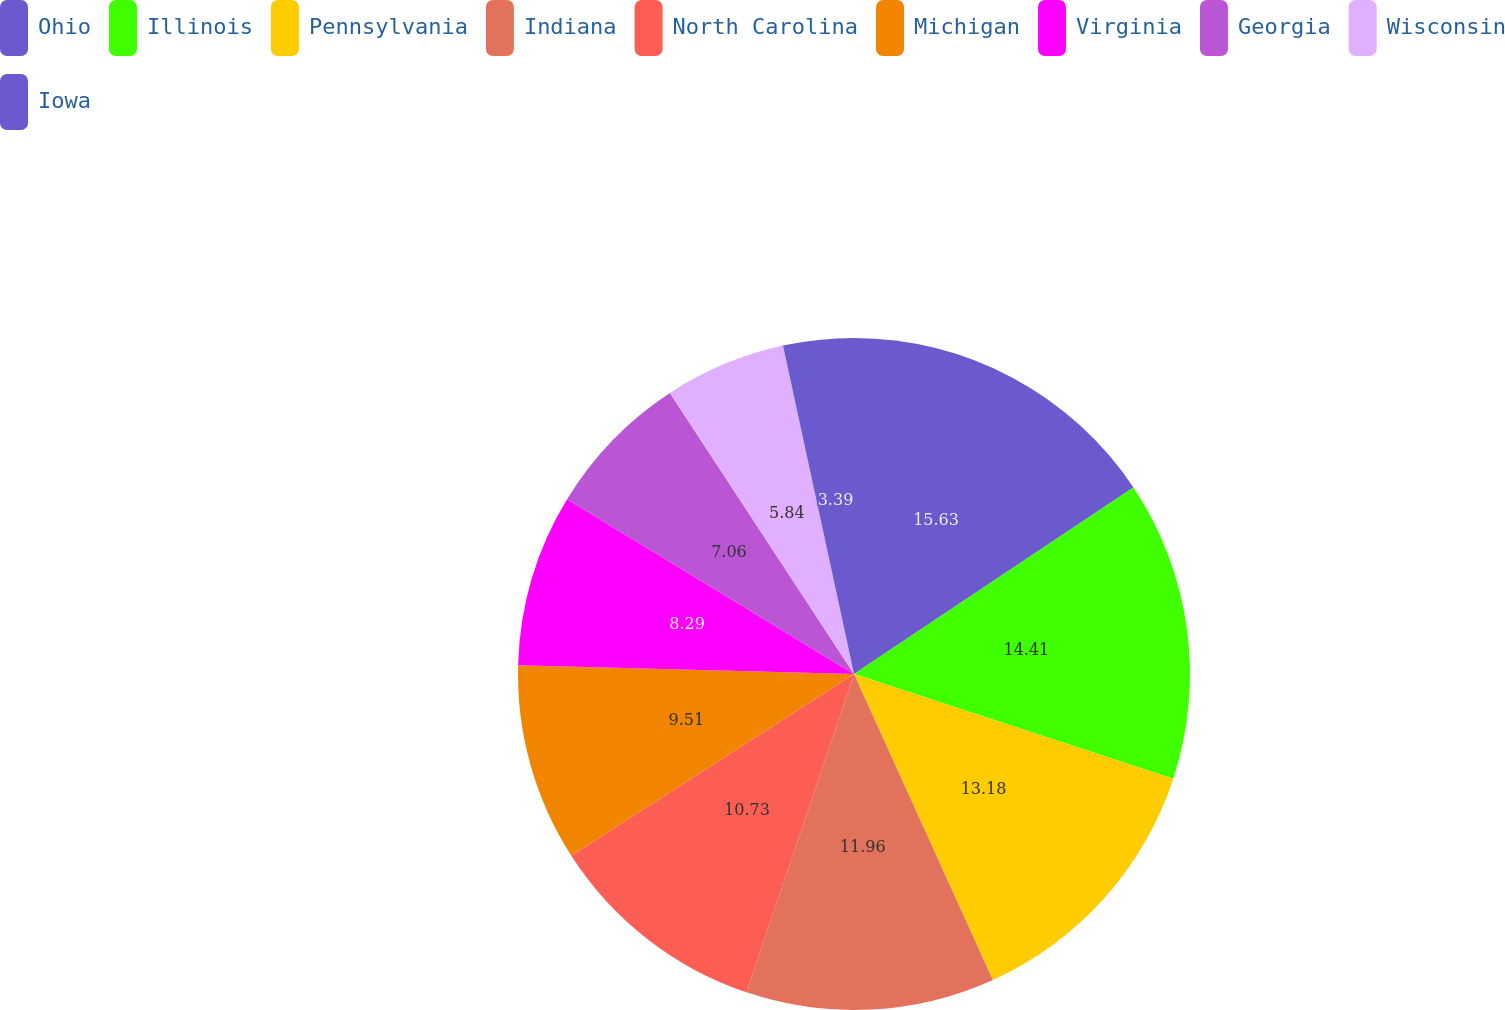<chart> <loc_0><loc_0><loc_500><loc_500><pie_chart><fcel>Ohio<fcel>Illinois<fcel>Pennsylvania<fcel>Indiana<fcel>North Carolina<fcel>Michigan<fcel>Virginia<fcel>Georgia<fcel>Wisconsin<fcel>Iowa<nl><fcel>15.63%<fcel>14.41%<fcel>13.18%<fcel>11.96%<fcel>10.73%<fcel>9.51%<fcel>8.29%<fcel>7.06%<fcel>5.84%<fcel>3.39%<nl></chart> 